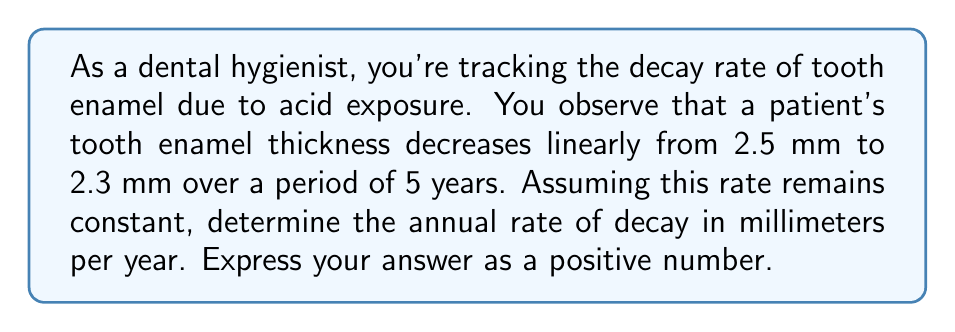Solve this math problem. To solve this problem, we'll use the concept of linear equations and rate of change. Let's break it down step-by-step:

1) We have two points:
   At time $t_1 = 0$ years, thickness $y_1 = 2.5$ mm
   At time $t_2 = 5$ years, thickness $y_2 = 2.3$ mm

2) The rate of decay is the slope of the line between these two points. We can calculate this using the slope formula:

   $$ \text{Rate of decay} = -\frac{\text{Change in thickness}}{\text{Change in time}} = -\frac{y_2 - y_1}{t_2 - t_1} $$

3) Substituting our values:

   $$ \text{Rate of decay} = -\frac{2.3 - 2.5}{5 - 0} = -\frac{-0.2}{5} $$

4) Simplifying:

   $$ \text{Rate of decay} = \frac{0.2}{5} = 0.04 $$

5) The question asks for the rate as a positive number, so our final answer is 0.04 mm/year.

This means the tooth enamel is decaying at a rate of 0.04 millimeters per year.
Answer: 0.04 mm/year 